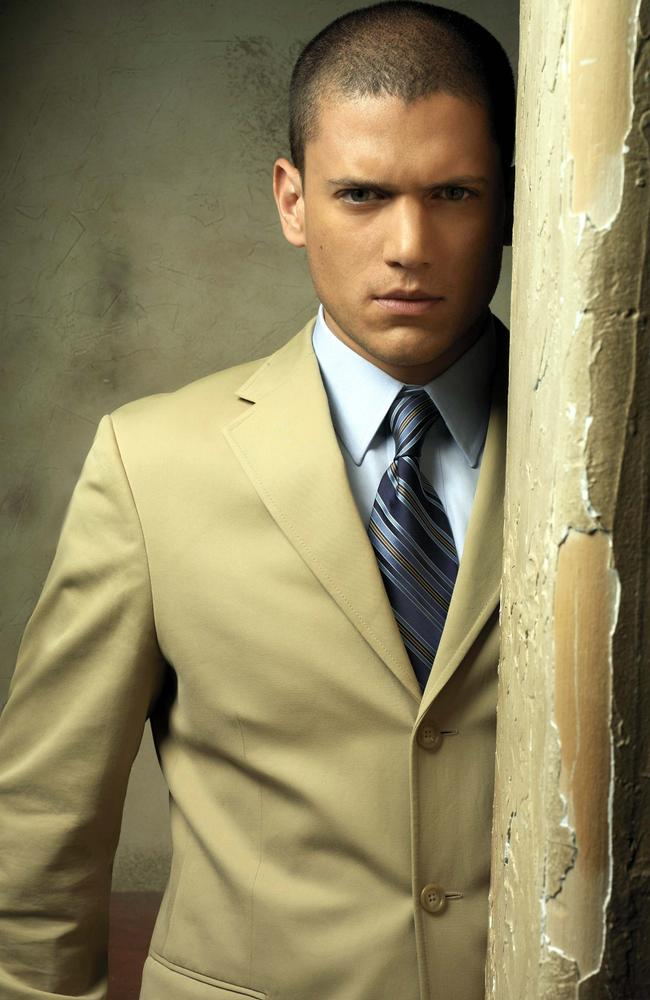Tell me a story about the person in the image. In a busy city, John, a high-profile lawyer, found solace in the quiet corners of old, forgotten buildings. The rustic charm of the dilapidated walls reminded him of simpler times. Today, as he leaned against the peeling paint, he thought about the case that could make or break his career. His serious expression was not just about the case, but also about the impact it would have on the lives of those involved. Every crack on the wall seemed to mirror the fractures in his own life, pushing him to reflect deeply on his path. This image captures not just his physical presence but the weight of his thoughts and the complexity of his journey. 